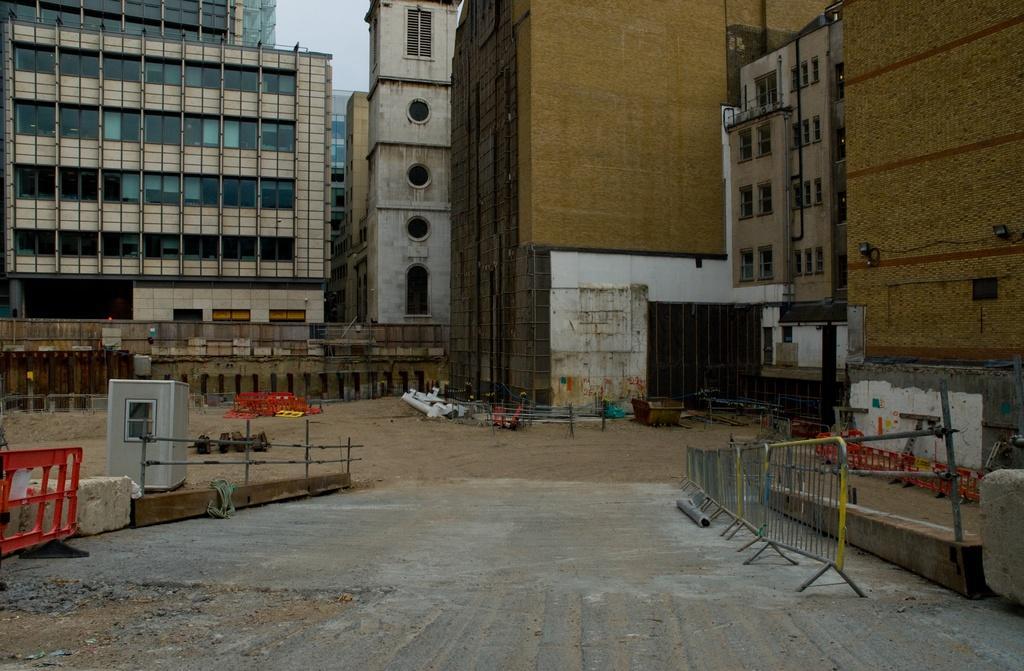In one or two sentences, can you explain what this image depicts? In this picture there are buildings. In the foreground there are railings. There are lights and there is a pipe on the wall. At the top there is sky. At the bottom there is mud. 